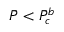Convert formula to latex. <formula><loc_0><loc_0><loc_500><loc_500>\ B a r { P } < \ B a r { P } _ { c } ^ { b }</formula> 